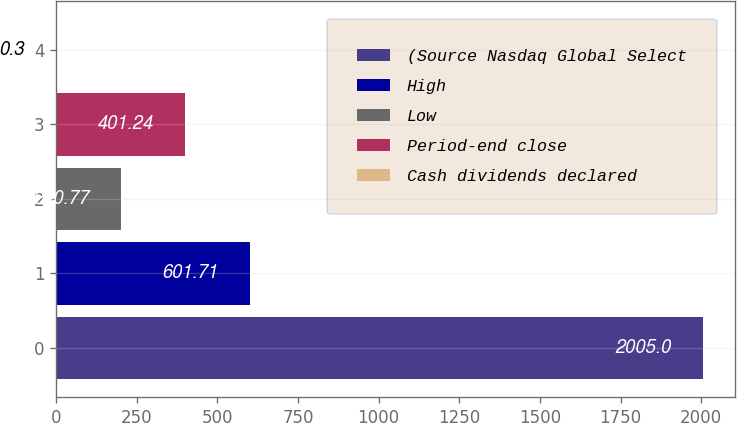Convert chart to OTSL. <chart><loc_0><loc_0><loc_500><loc_500><bar_chart><fcel>(Source Nasdaq Global Select<fcel>High<fcel>Low<fcel>Period-end close<fcel>Cash dividends declared<nl><fcel>2005<fcel>601.71<fcel>200.77<fcel>401.24<fcel>0.3<nl></chart> 